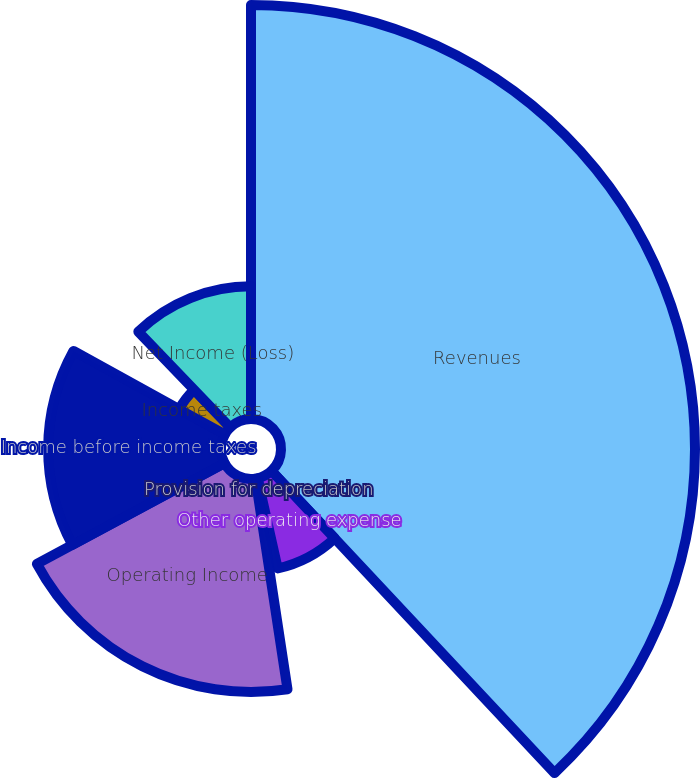Convert chart. <chart><loc_0><loc_0><loc_500><loc_500><pie_chart><fcel>Revenues<fcel>Other operating expense<fcel>Provision for depreciation<fcel>Operating Income<fcel>Income before income taxes<fcel>Income taxes<fcel>Net Income (Loss)<nl><fcel>38.02%<fcel>8.48%<fcel>1.1%<fcel>19.56%<fcel>15.87%<fcel>4.79%<fcel>12.18%<nl></chart> 